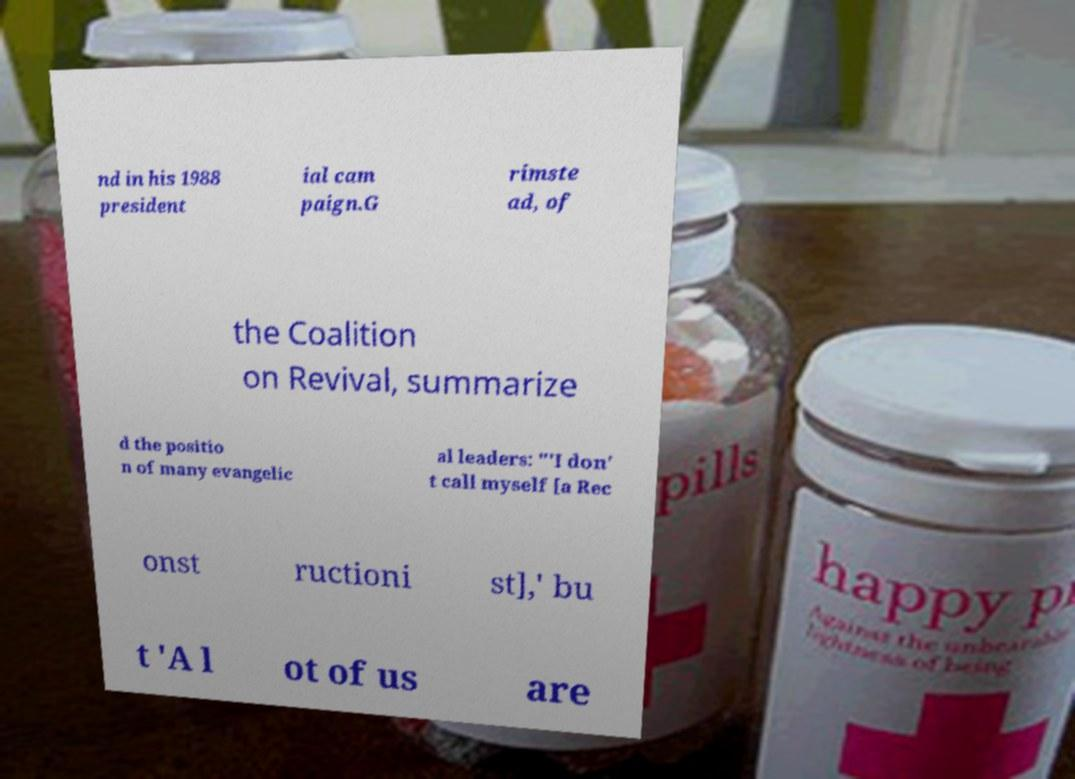I need the written content from this picture converted into text. Can you do that? nd in his 1988 president ial cam paign.G rimste ad, of the Coalition on Revival, summarize d the positio n of many evangelic al leaders: "'I don' t call myself [a Rec onst ructioni st],' bu t 'A l ot of us are 